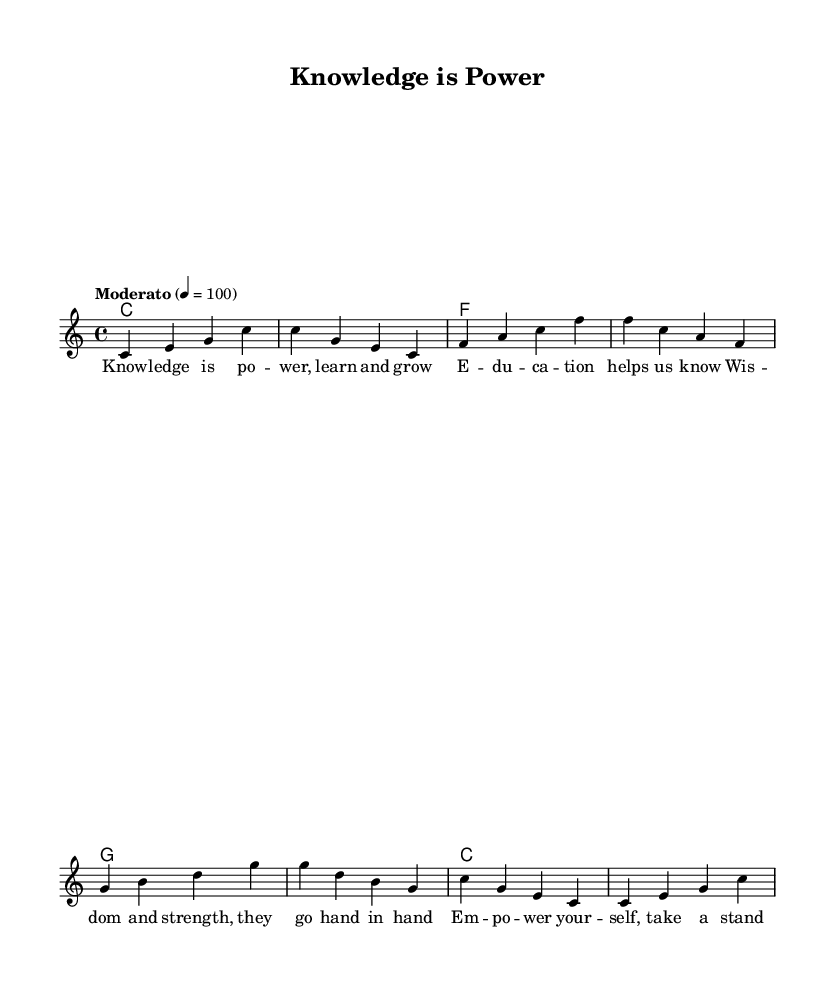What is the key signature of this music? The key signature is indicated at the beginning of the staff. In this case, it shows no sharps or flats, which signifies that the piece is in C major.
Answer: C major What is the time signature of the piece? The time signature is located near the beginning of the sheet music, represented as a fraction. Here, it is shown as 4/4, meaning there are four beats in each measure and the quarter note gets one beat.
Answer: 4/4 What is the tempo for this song? The tempo marking is present in italics above the staff. "Moderato" indicates a moderate pace, and the number 4 = 100 specifies the beats per minute.
Answer: Moderato, 100 How many measures are in the piece? To determine the number of measures, count each vertical line that separates the notes into groups. Here, there are eight measures in total.
Answer: 8 What are the first two notes of the melody? The first two notes are seen in the melody line; they are the notes C and E, appearing at the start of the first measure.
Answer: C, E How does the harmony change in the piece? The harmony is indicated in the chord mode below the melody. It follows a sequence of C, F, G, and back to C, which shows the chord progression throughout the piece.
Answer: C, F, G, C What theme is conveyed by the lyrics? The lyrics express themes of empowerment and education, highlighting the importance of knowledge and taking action. This is conveyed through phrases like "Knowledge is power" and "Empower yourself."
Answer: Empowerment and education 